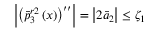<formula> <loc_0><loc_0><loc_500><loc_500>\left | { { \left ( \bar { p } _ { 3 } ^ { r 2 } \left ( x \right ) \right ) } ^ { \prime \prime } } \right | = \left | 2 { { { \bar { a } } } _ { 2 } } \right | \leq { { \zeta } _ { 1 } }</formula> 